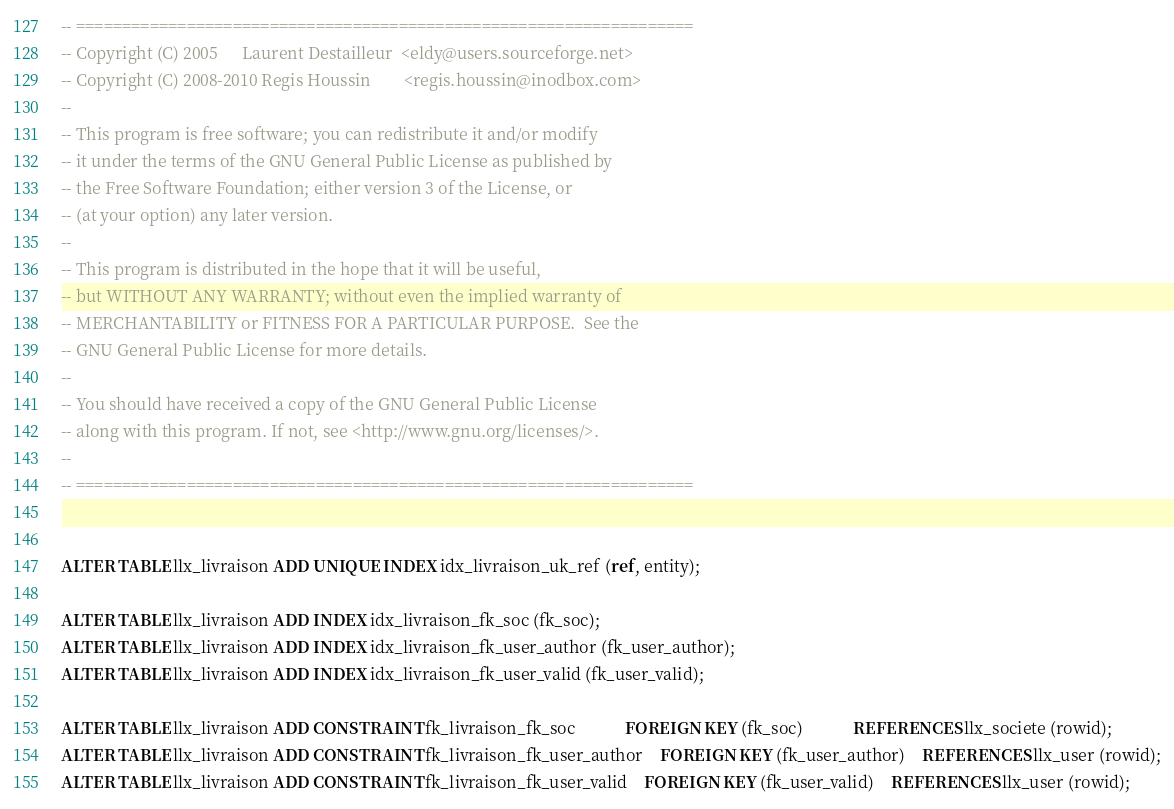<code> <loc_0><loc_0><loc_500><loc_500><_SQL_>-- ===================================================================
-- Copyright (C) 2005      Laurent Destailleur  <eldy@users.sourceforge.net>
-- Copyright (C) 2008-2010 Regis Houssin        <regis.houssin@inodbox.com>
--
-- This program is free software; you can redistribute it and/or modify
-- it under the terms of the GNU General Public License as published by
-- the Free Software Foundation; either version 3 of the License, or
-- (at your option) any later version.
--
-- This program is distributed in the hope that it will be useful,
-- but WITHOUT ANY WARRANTY; without even the implied warranty of
-- MERCHANTABILITY or FITNESS FOR A PARTICULAR PURPOSE.  See the
-- GNU General Public License for more details.
--
-- You should have received a copy of the GNU General Public License
-- along with this program. If not, see <http://www.gnu.org/licenses/>.
--
-- ===================================================================


ALTER TABLE llx_livraison ADD UNIQUE INDEX idx_livraison_uk_ref (ref, entity);

ALTER TABLE llx_livraison ADD INDEX idx_livraison_fk_soc (fk_soc);
ALTER TABLE llx_livraison ADD INDEX idx_livraison_fk_user_author (fk_user_author);
ALTER TABLE llx_livraison ADD INDEX idx_livraison_fk_user_valid (fk_user_valid);

ALTER TABLE llx_livraison ADD CONSTRAINT fk_livraison_fk_soc			FOREIGN KEY (fk_soc)			REFERENCES llx_societe (rowid);
ALTER TABLE llx_livraison ADD CONSTRAINT fk_livraison_fk_user_author	FOREIGN KEY (fk_user_author)	REFERENCES llx_user (rowid);
ALTER TABLE llx_livraison ADD CONSTRAINT fk_livraison_fk_user_valid	FOREIGN KEY (fk_user_valid)	REFERENCES llx_user (rowid);
</code> 